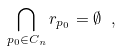<formula> <loc_0><loc_0><loc_500><loc_500>\bigcap _ { p _ { 0 } \in C _ { n } } r _ { p _ { 0 } } = \emptyset \ ,</formula> 